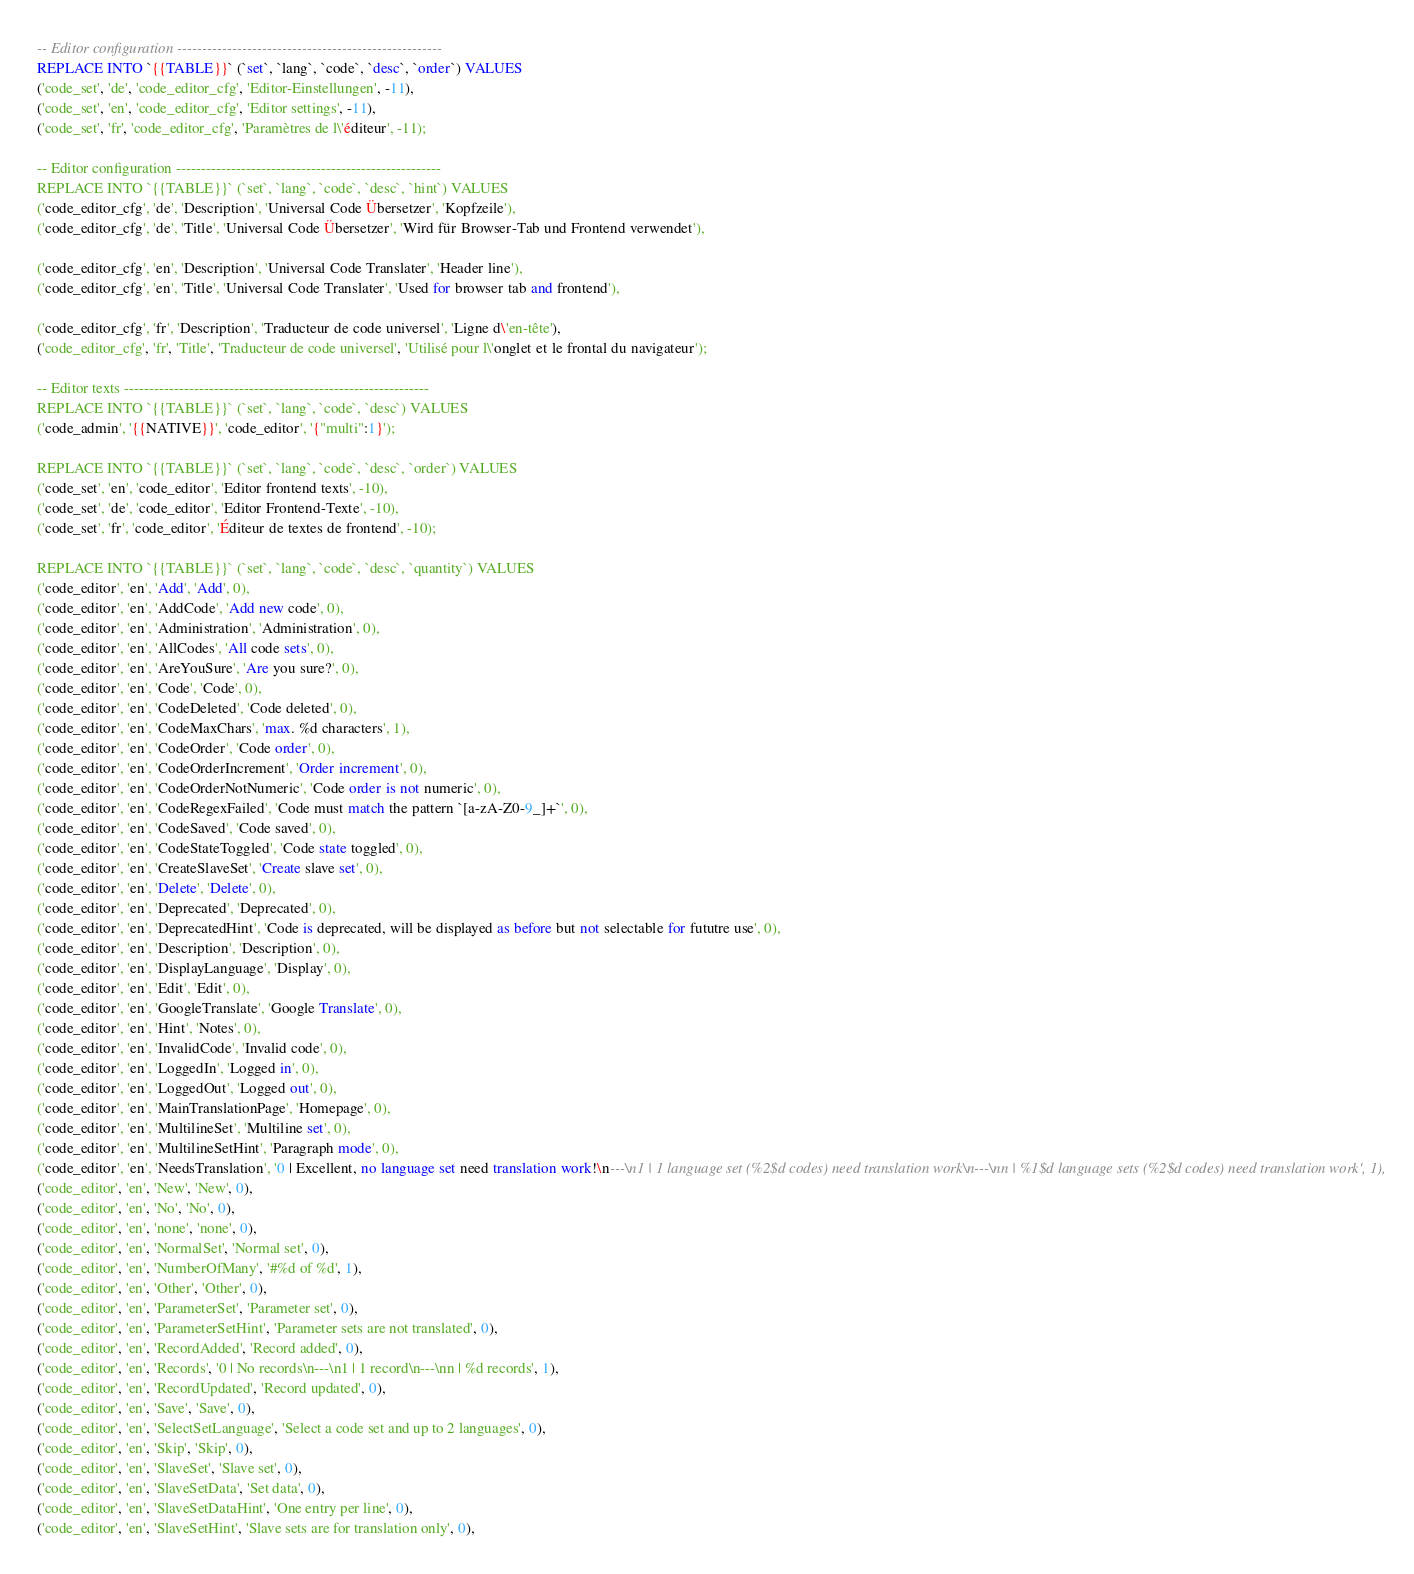Convert code to text. <code><loc_0><loc_0><loc_500><loc_500><_SQL_>-- Editor configuration -----------------------------------------------------
REPLACE INTO `{{TABLE}}` (`set`, `lang`, `code`, `desc`, `order`) VALUES
('code_set', 'de', 'code_editor_cfg', 'Editor-Einstellungen', -11),
('code_set', 'en', 'code_editor_cfg', 'Editor settings', -11),
('code_set', 'fr', 'code_editor_cfg', 'Paramètres de l\'éditeur', -11);

-- Editor configuration -----------------------------------------------------
REPLACE INTO `{{TABLE}}` (`set`, `lang`, `code`, `desc`, `hint`) VALUES
('code_editor_cfg', 'de', 'Description', 'Universal Code Übersetzer', 'Kopfzeile'),
('code_editor_cfg', 'de', 'Title', 'Universal Code Übersetzer', 'Wird für Browser-Tab und Frontend verwendet'),

('code_editor_cfg', 'en', 'Description', 'Universal Code Translater', 'Header line'),
('code_editor_cfg', 'en', 'Title', 'Universal Code Translater', 'Used for browser tab and frontend'),

('code_editor_cfg', 'fr', 'Description', 'Traducteur de code universel', 'Ligne d\'en-tête'),
('code_editor_cfg', 'fr', 'Title', 'Traducteur de code universel', 'Utilisé pour l\'onglet et le frontal du navigateur');

-- Editor texts -------------------------------------------------------------
REPLACE INTO `{{TABLE}}` (`set`, `lang`, `code`, `desc`) VALUES
('code_admin', '{{NATIVE}}', 'code_editor', '{"multi":1}');

REPLACE INTO `{{TABLE}}` (`set`, `lang`, `code`, `desc`, `order`) VALUES
('code_set', 'en', 'code_editor', 'Editor frontend texts', -10),
('code_set', 'de', 'code_editor', 'Editor Frontend-Texte', -10),
('code_set', 'fr', 'code_editor', 'Éditeur de textes de frontend', -10);

REPLACE INTO `{{TABLE}}` (`set`, `lang`, `code`, `desc`, `quantity`) VALUES
('code_editor', 'en', 'Add', 'Add', 0),
('code_editor', 'en', 'AddCode', 'Add new code', 0),
('code_editor', 'en', 'Administration', 'Administration', 0),
('code_editor', 'en', 'AllCodes', 'All code sets', 0),
('code_editor', 'en', 'AreYouSure', 'Are you sure?', 0),
('code_editor', 'en', 'Code', 'Code', 0),
('code_editor', 'en', 'CodeDeleted', 'Code deleted', 0),
('code_editor', 'en', 'CodeMaxChars', 'max. %d characters', 1),
('code_editor', 'en', 'CodeOrder', 'Code order', 0),
('code_editor', 'en', 'CodeOrderIncrement', 'Order increment', 0),
('code_editor', 'en', 'CodeOrderNotNumeric', 'Code order is not numeric', 0),
('code_editor', 'en', 'CodeRegexFailed', 'Code must match the pattern `[a-zA-Z0-9_]+`', 0),
('code_editor', 'en', 'CodeSaved', 'Code saved', 0),
('code_editor', 'en', 'CodeStateToggled', 'Code state toggled', 0),
('code_editor', 'en', 'CreateSlaveSet', 'Create slave set', 0),
('code_editor', 'en', 'Delete', 'Delete', 0),
('code_editor', 'en', 'Deprecated', 'Deprecated', 0),
('code_editor', 'en', 'DeprecatedHint', 'Code is deprecated, will be displayed as before but not selectable for fututre use', 0),
('code_editor', 'en', 'Description', 'Description', 0),
('code_editor', 'en', 'DisplayLanguage', 'Display', 0),
('code_editor', 'en', 'Edit', 'Edit', 0),
('code_editor', 'en', 'GoogleTranslate', 'Google Translate', 0),
('code_editor', 'en', 'Hint', 'Notes', 0),
('code_editor', 'en', 'InvalidCode', 'Invalid code', 0),
('code_editor', 'en', 'LoggedIn', 'Logged in', 0),
('code_editor', 'en', 'LoggedOut', 'Logged out', 0),
('code_editor', 'en', 'MainTranslationPage', 'Homepage', 0),
('code_editor', 'en', 'MultilineSet', 'Multiline set', 0),
('code_editor', 'en', 'MultilineSetHint', 'Paragraph mode', 0),
('code_editor', 'en', 'NeedsTranslation', '0 | Excellent, no language set need translation work!\n---\n1 | 1 language set (%2$d codes) need translation work\n---\nn | %1$d language sets (%2$d codes) need translation work', 1),
('code_editor', 'en', 'New', 'New', 0),
('code_editor', 'en', 'No', 'No', 0),
('code_editor', 'en', 'none', 'none', 0),
('code_editor', 'en', 'NormalSet', 'Normal set', 0),
('code_editor', 'en', 'NumberOfMany', '#%d of %d', 1),
('code_editor', 'en', 'Other', 'Other', 0),
('code_editor', 'en', 'ParameterSet', 'Parameter set', 0),
('code_editor', 'en', 'ParameterSetHint', 'Parameter sets are not translated', 0),
('code_editor', 'en', 'RecordAdded', 'Record added', 0),
('code_editor', 'en', 'Records', '0 | No records\n---\n1 | 1 record\n---\nn | %d records', 1),
('code_editor', 'en', 'RecordUpdated', 'Record updated', 0),
('code_editor', 'en', 'Save', 'Save', 0),
('code_editor', 'en', 'SelectSetLanguage', 'Select a code set and up to 2 languages', 0),
('code_editor', 'en', 'Skip', 'Skip', 0),
('code_editor', 'en', 'SlaveSet', 'Slave set', 0),
('code_editor', 'en', 'SlaveSetData', 'Set data', 0),
('code_editor', 'en', 'SlaveSetDataHint', 'One entry per line', 0),
('code_editor', 'en', 'SlaveSetHint', 'Slave sets are for translation only', 0),</code> 